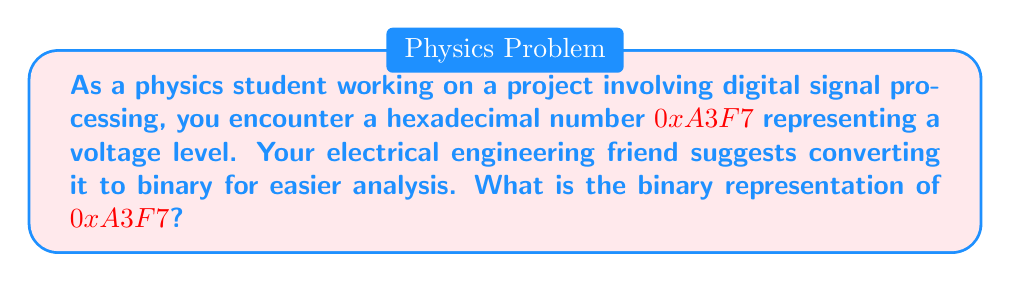Solve this math problem. To convert a hexadecimal number to binary, we can follow these steps:

1) First, recall that each hexadecimal digit represents 4 binary digits (bits). 

2) We can create a conversion table for hexadecimal to binary:

   0 = 0000   4 = 0100   8 = 1000   C = 1100
   1 = 0001   5 = 0101   9 = 1001   D = 1101
   2 = 0010   6 = 0110   A = 1010   E = 1110
   3 = 0011   7 = 0111   B = 1011   F = 1111

3) Now, let's convert each hexadecimal digit of $0xA3F7$:

   A = 1010
   3 = 0011
   F = 1111
   7 = 0111

4) Concatenate these binary numbers in the same order:

   $$(1010)(0011)(1111)(0111)$$

5) Therefore, the binary representation is:

   $$1010001111110111$$

This method works because each hexadecimal digit precisely represents 4 binary digits, making the conversion straightforward once you know the correspondences.
Answer: $1010001111110111$ 